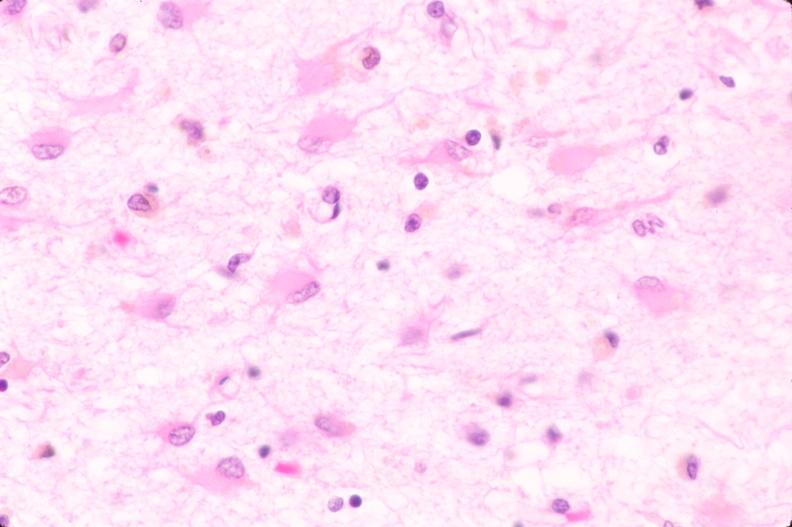what is present?
Answer the question using a single word or phrase. Nervous 